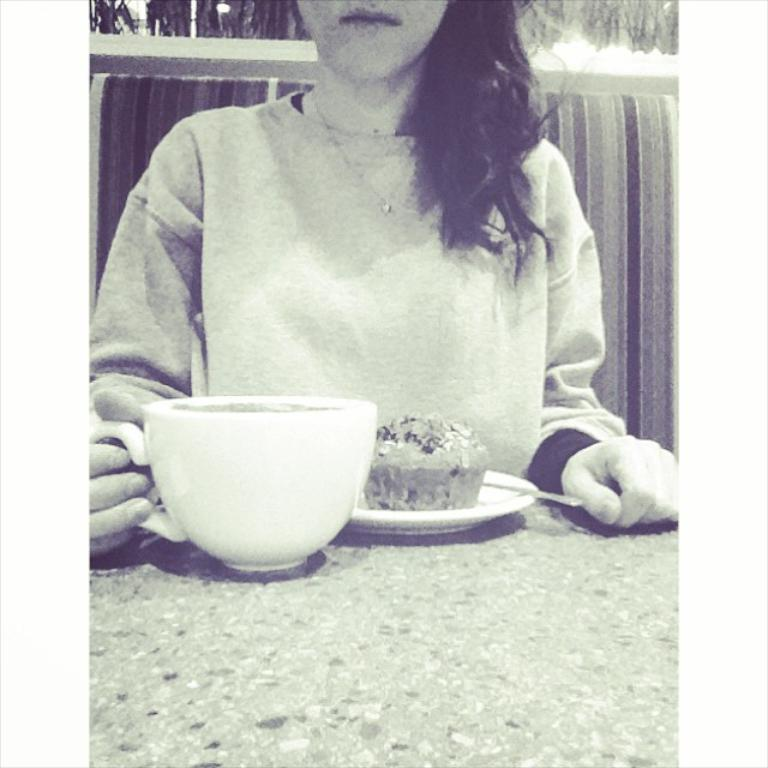What is the woman in the image doing? The woman is sitting in the image. What is the woman holding in the image? The woman is holding a cup. What can be seen on the table in the image? There is a plate with a muffin and another cup on the table. What type of coat is the woman wearing in the image? There is no coat visible in the image. How does the sponge help the woman in the image? There is no sponge present in the image, so it cannot help the woman. 